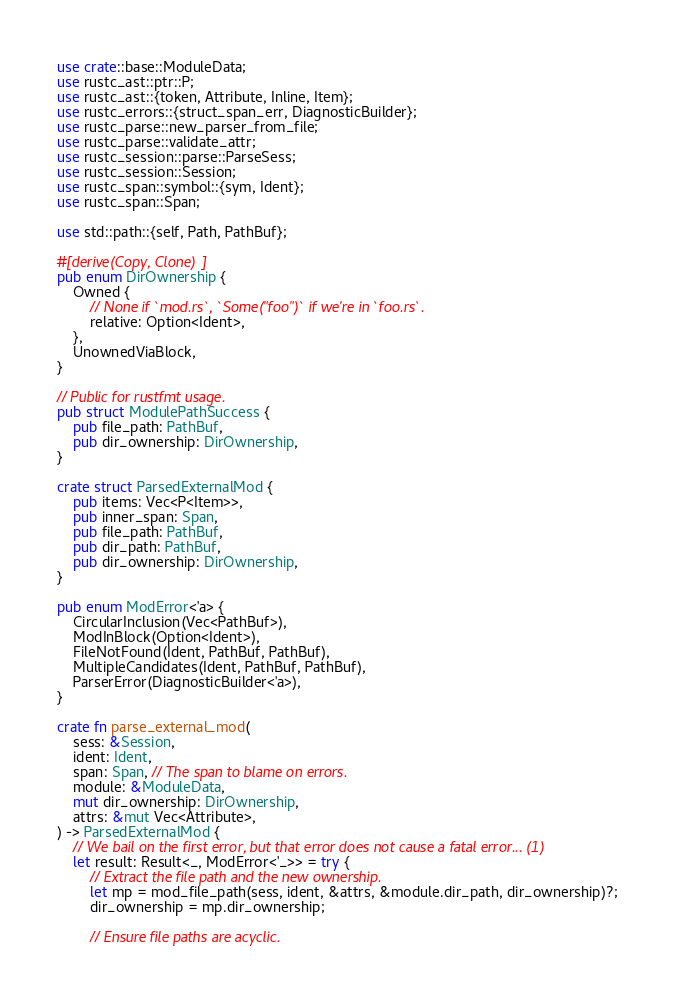<code> <loc_0><loc_0><loc_500><loc_500><_Rust_>use crate::base::ModuleData;
use rustc_ast::ptr::P;
use rustc_ast::{token, Attribute, Inline, Item};
use rustc_errors::{struct_span_err, DiagnosticBuilder};
use rustc_parse::new_parser_from_file;
use rustc_parse::validate_attr;
use rustc_session::parse::ParseSess;
use rustc_session::Session;
use rustc_span::symbol::{sym, Ident};
use rustc_span::Span;

use std::path::{self, Path, PathBuf};

#[derive(Copy, Clone)]
pub enum DirOwnership {
    Owned {
        // None if `mod.rs`, `Some("foo")` if we're in `foo.rs`.
        relative: Option<Ident>,
    },
    UnownedViaBlock,
}

// Public for rustfmt usage.
pub struct ModulePathSuccess {
    pub file_path: PathBuf,
    pub dir_ownership: DirOwnership,
}

crate struct ParsedExternalMod {
    pub items: Vec<P<Item>>,
    pub inner_span: Span,
    pub file_path: PathBuf,
    pub dir_path: PathBuf,
    pub dir_ownership: DirOwnership,
}

pub enum ModError<'a> {
    CircularInclusion(Vec<PathBuf>),
    ModInBlock(Option<Ident>),
    FileNotFound(Ident, PathBuf, PathBuf),
    MultipleCandidates(Ident, PathBuf, PathBuf),
    ParserError(DiagnosticBuilder<'a>),
}

crate fn parse_external_mod(
    sess: &Session,
    ident: Ident,
    span: Span, // The span to blame on errors.
    module: &ModuleData,
    mut dir_ownership: DirOwnership,
    attrs: &mut Vec<Attribute>,
) -> ParsedExternalMod {
    // We bail on the first error, but that error does not cause a fatal error... (1)
    let result: Result<_, ModError<'_>> = try {
        // Extract the file path and the new ownership.
        let mp = mod_file_path(sess, ident, &attrs, &module.dir_path, dir_ownership)?;
        dir_ownership = mp.dir_ownership;

        // Ensure file paths are acyclic.</code> 